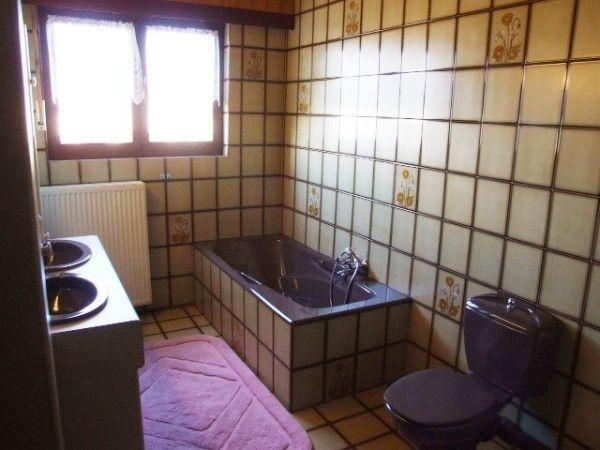What happens in this room?

Choices:
A) exercising
B) watching tv
C) washing hands
D) writing letters washing hands 